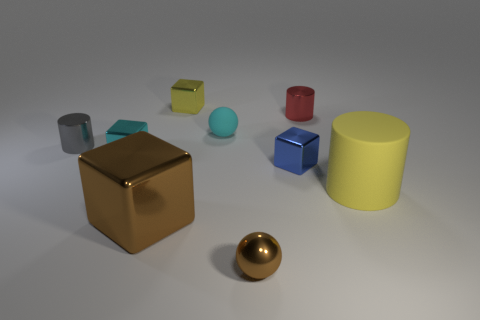Subtract all cyan metal cubes. How many cubes are left? 3 Subtract all cyan balls. How many balls are left? 1 Add 1 shiny objects. How many objects exist? 10 Subtract all blocks. How many objects are left? 5 Subtract 1 spheres. How many spheres are left? 1 Subtract 0 gray spheres. How many objects are left? 9 Subtract all yellow blocks. Subtract all purple cylinders. How many blocks are left? 3 Subtract all large brown shiny cubes. Subtract all small cyan spheres. How many objects are left? 7 Add 4 large cylinders. How many large cylinders are left? 5 Add 2 yellow things. How many yellow things exist? 4 